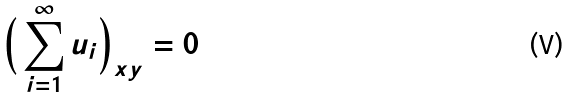Convert formula to latex. <formula><loc_0><loc_0><loc_500><loc_500>\Big { ( } \sum _ { i = 1 } ^ { \infty } u _ { i } \Big { ) } _ { x y } = 0</formula> 